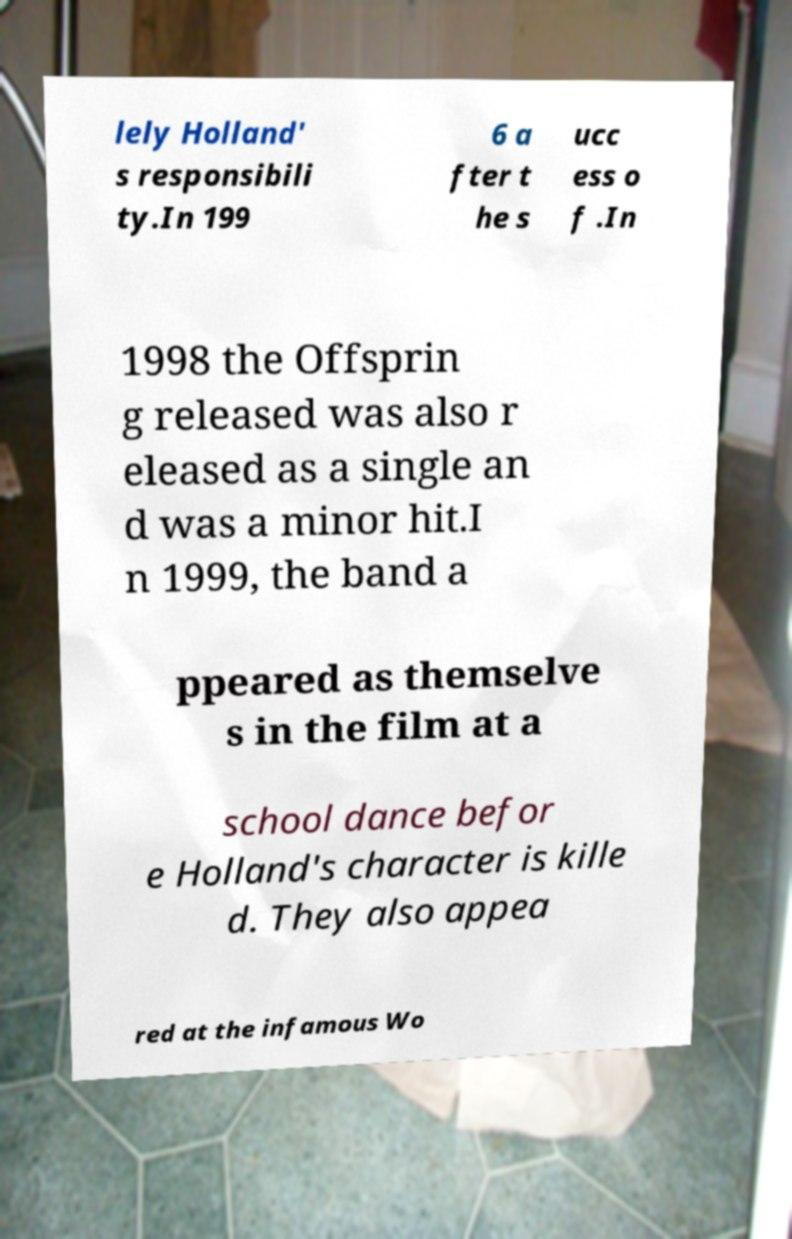Please read and relay the text visible in this image. What does it say? lely Holland' s responsibili ty.In 199 6 a fter t he s ucc ess o f .In 1998 the Offsprin g released was also r eleased as a single an d was a minor hit.I n 1999, the band a ppeared as themselve s in the film at a school dance befor e Holland's character is kille d. They also appea red at the infamous Wo 